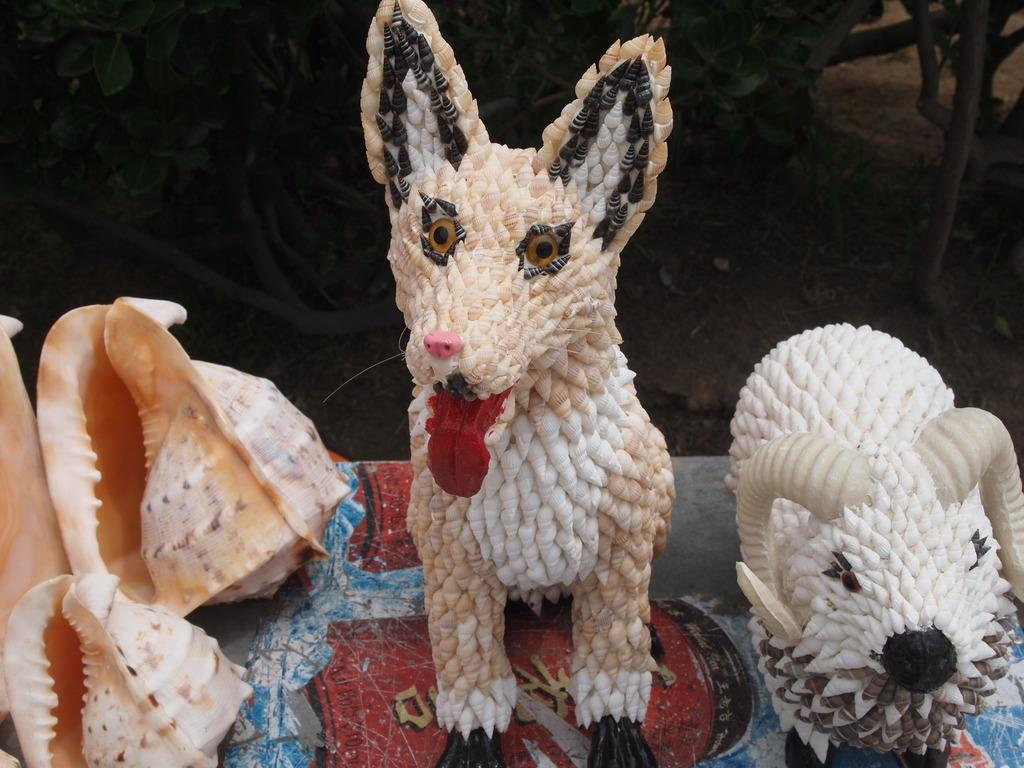What type of objects are present in the image? There are two toy animals and seashells in the image. What colors are the toy animals? The toy animals are in white and cream color. What colors are the seashells? The seashells are in cream and white color. What type of unit is being measured in the image? There is no unit being measured in the image; it features toy animals and seashells. Can you tell me how many cacti are present in the image? There are no cacti present in the image; it features toy animals and seashells. 